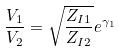Convert formula to latex. <formula><loc_0><loc_0><loc_500><loc_500>\frac { V _ { 1 } } { V _ { 2 } } = \sqrt { \frac { Z _ { I 1 } } { Z _ { I 2 } } } e ^ { \gamma _ { 1 } }</formula> 